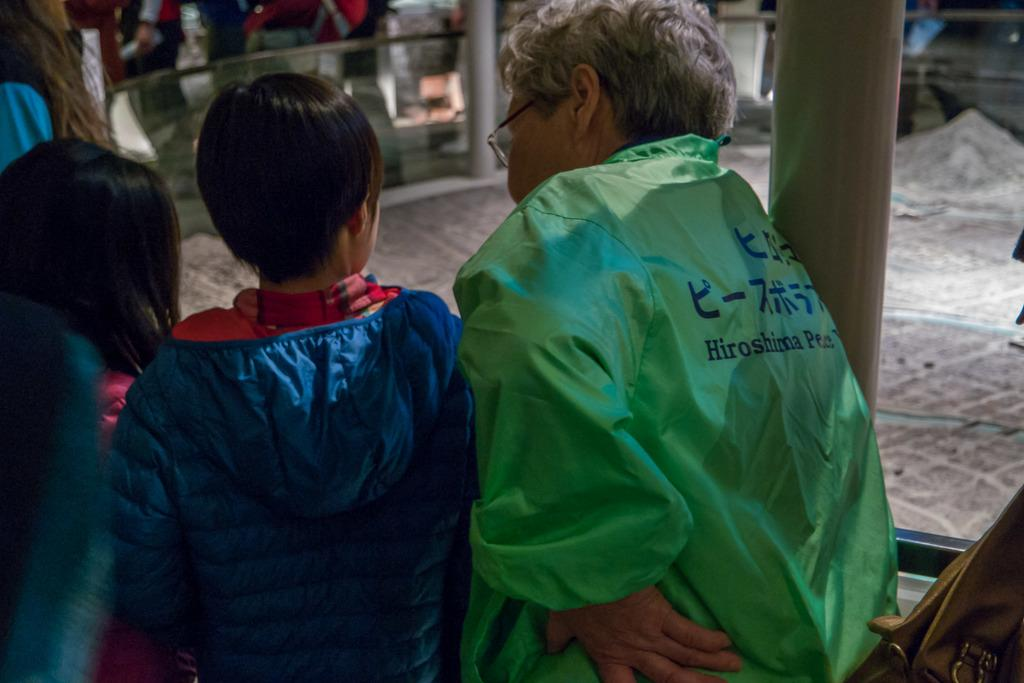What is present in the image involving people? There are persons standing in the image. What type of architectural feature can be seen in the image? There is a glass railing in the image. What type of model is visible in the image? There is a miniature of the city in the image. How many brothers are visible in the image? There is no mention of brothers in the image, so it cannot be determined from the picture. What type of force is being applied to the glass railing in the image? There is no indication of any force being applied to the glass railing in the image. How many dogs are present in the image? There is no mention of dogs in the image, so it cannot be determined from the picture. 